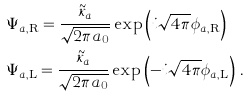<formula> <loc_0><loc_0><loc_500><loc_500>& \Psi _ { a , \text {R} } = \frac { { \tilde { \kappa } } _ { a } } { \sqrt { 2 \pi a _ { 0 } } } \exp \left ( i \sqrt { 4 \pi } \phi _ { a , \text {R} } \right ) \\ & \Psi _ { a , \text {L} } = \frac { { \tilde { \kappa } } _ { a } } { \sqrt { 2 \pi a _ { 0 } } } \exp \left ( - i \sqrt { 4 \pi } \phi _ { a , \text {L} } \right ) \, .</formula> 